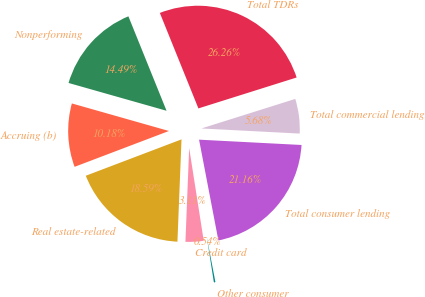Convert chart. <chart><loc_0><loc_0><loc_500><loc_500><pie_chart><fcel>Real estate-related<fcel>Credit card<fcel>Other consumer<fcel>Total consumer lending<fcel>Total commercial lending<fcel>Total TDRs<fcel>Nonperforming<fcel>Accruing (b)<nl><fcel>18.59%<fcel>3.11%<fcel>0.54%<fcel>21.16%<fcel>5.68%<fcel>26.26%<fcel>14.49%<fcel>10.18%<nl></chart> 